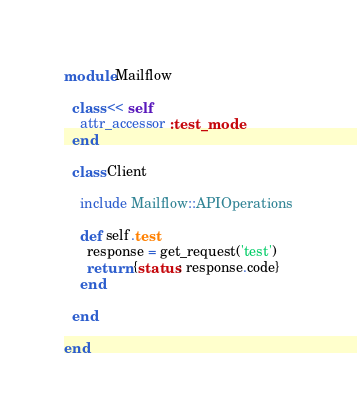Convert code to text. <code><loc_0><loc_0><loc_500><loc_500><_Ruby_>module Mailflow

  class << self
    attr_accessor :test_mode
  end

  class Client

    include Mailflow::APIOperations

    def self.test
      response = get_request('test')
      return {status: response.code}
    end

  end

end
</code> 